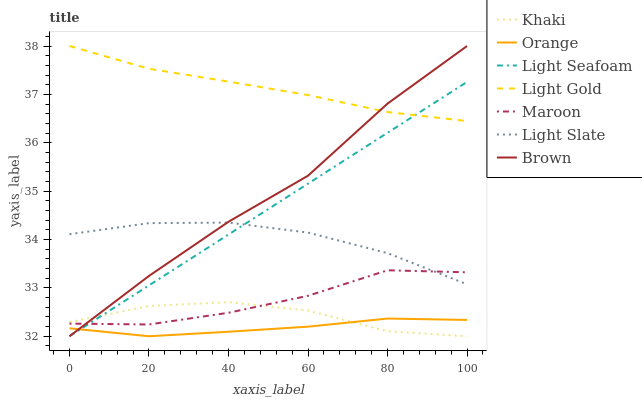Does Orange have the minimum area under the curve?
Answer yes or no. Yes. Does Light Gold have the maximum area under the curve?
Answer yes or no. Yes. Does Khaki have the minimum area under the curve?
Answer yes or no. No. Does Khaki have the maximum area under the curve?
Answer yes or no. No. Is Light Seafoam the smoothest?
Answer yes or no. Yes. Is Brown the roughest?
Answer yes or no. Yes. Is Khaki the smoothest?
Answer yes or no. No. Is Khaki the roughest?
Answer yes or no. No. Does Brown have the lowest value?
Answer yes or no. Yes. Does Light Slate have the lowest value?
Answer yes or no. No. Does Light Gold have the highest value?
Answer yes or no. Yes. Does Khaki have the highest value?
Answer yes or no. No. Is Khaki less than Light Gold?
Answer yes or no. Yes. Is Light Slate greater than Khaki?
Answer yes or no. Yes. Does Maroon intersect Light Seafoam?
Answer yes or no. Yes. Is Maroon less than Light Seafoam?
Answer yes or no. No. Is Maroon greater than Light Seafoam?
Answer yes or no. No. Does Khaki intersect Light Gold?
Answer yes or no. No. 